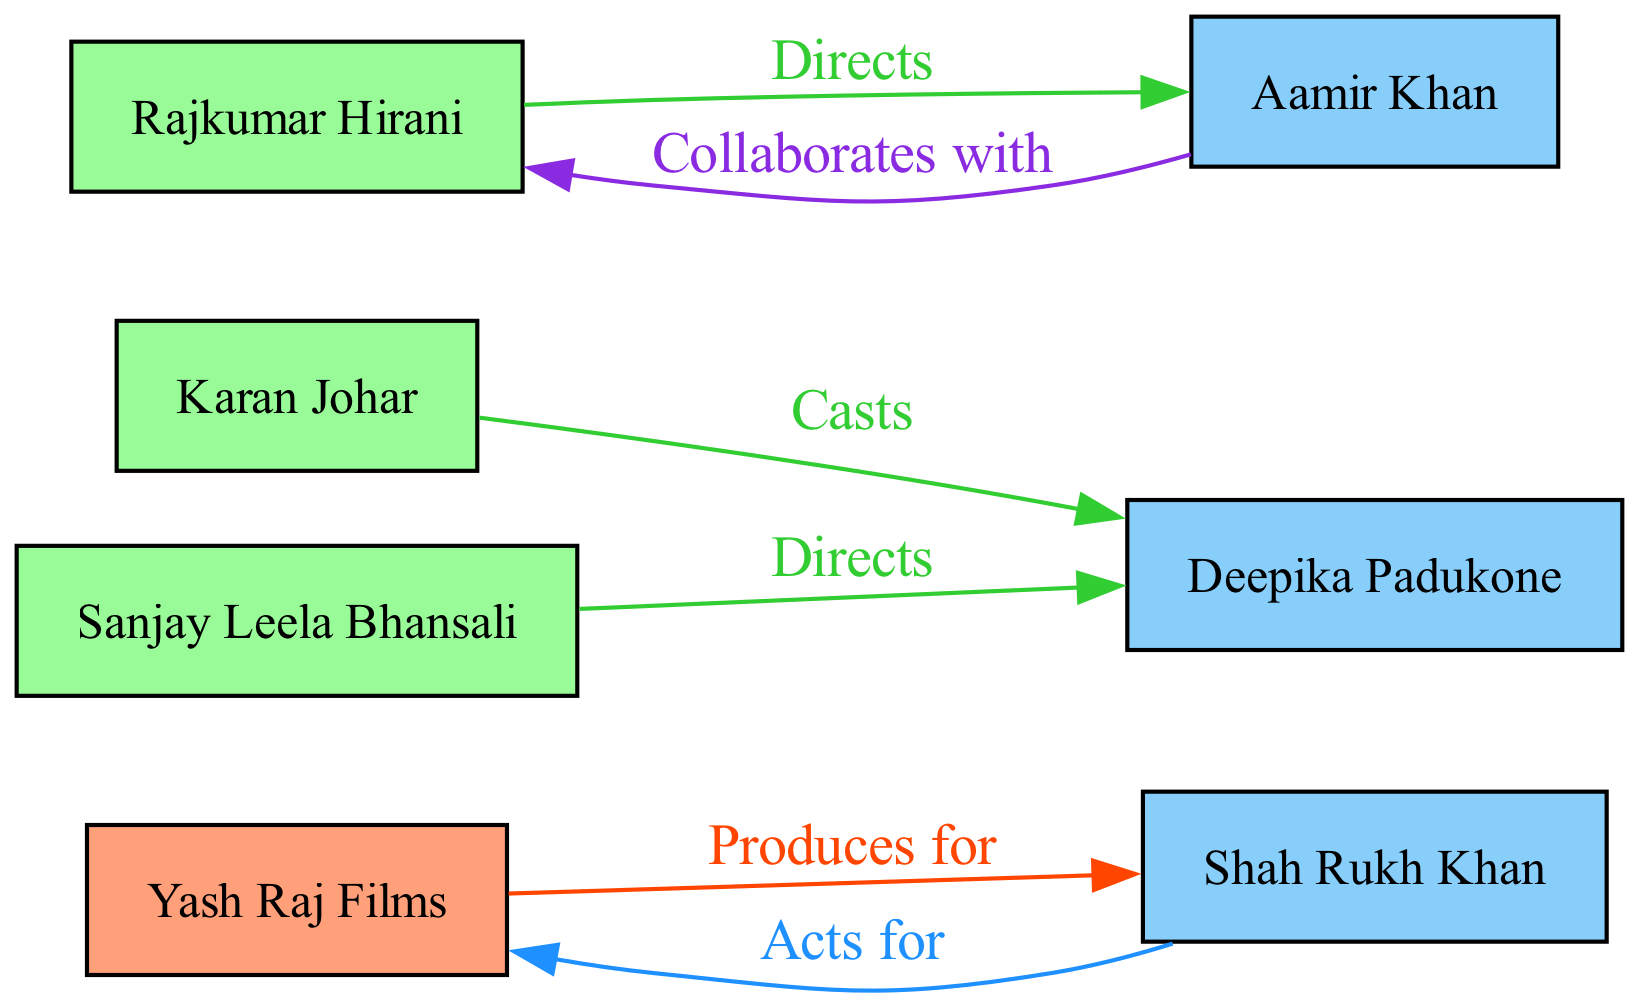What is the total number of nodes in the diagram? The diagram includes nodes for Yash Raj Films, Karan Johar, Shah Rukh Khan, Rajkumar Hirani, Aamir Khan, Deepika Padukone, and Sanjay Leela Bhansali, making a total of 7 nodes.
Answer: 7 Which actor does Yash Raj Films produce for? The edge labeled "Produces for" connects Yash Raj Films to Shah Rukh Khan, indicating that Yash Raj Films produces for him.
Answer: Shah Rukh Khan Who casts Deepika Padukone? The edge labeled "Casts" connects Karan Johar to Deepika Padukone, which shows that Karan Johar is responsible for casting her in films.
Answer: Karan Johar Which director collaborates with Aamir Khan? The edge shows that Aamir Khan collaborates with Rajkumar Hirani, indicating that Rajkumar Hirani is the director he collaborates with.
Answer: Rajkumar Hirani What is the relationship between Sanjay Leela Bhansali and Deepika Padukone? The label "Directs" on the edge from Sanjay Leela Bhansali to Deepika Padukone indicates that Sanjay Leela Bhansali directs her in films.
Answer: Directs How many edges are in the diagram? The diagram contains edges for the relationships: YRF to SLKhan, KJohar to DPadukone, RHirani to AKhan, SBhansali to DPadukone, SLKhan to YRF, and AKhan to RHirani, totaling 6 edges.
Answer: 6 Which actor acts for Yash Raj Films? The edge labeled "Acts for" connects Shah Rukh Khan to Yash Raj Films, indicating that he acts for this production company.
Answer: Shah Rukh Khan Who is directed by Rajkumar Hirani? The directed edge from Rajkumar Hirani to Aamir Khan, labeled "Directs," shows that Aamir Khan is the actor he directs.
Answer: Aamir Khan What color represents the production houses in the diagram? The diagram uses Light Salmon color to represent production houses, as can be seen with Yash Raj Films.
Answer: Light Salmon 